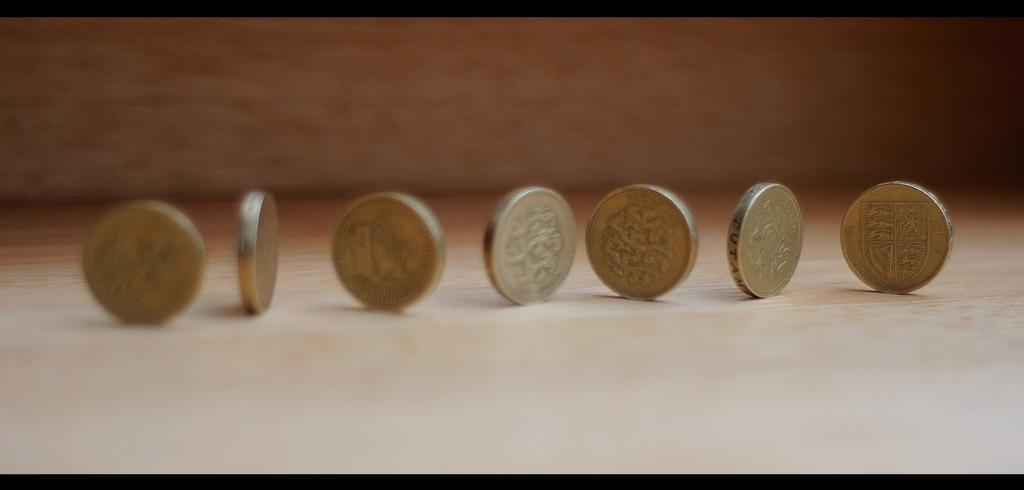Please provide a concise description of this image. In this picture we can see coins on the platform and in the background we can see it is blurry. 